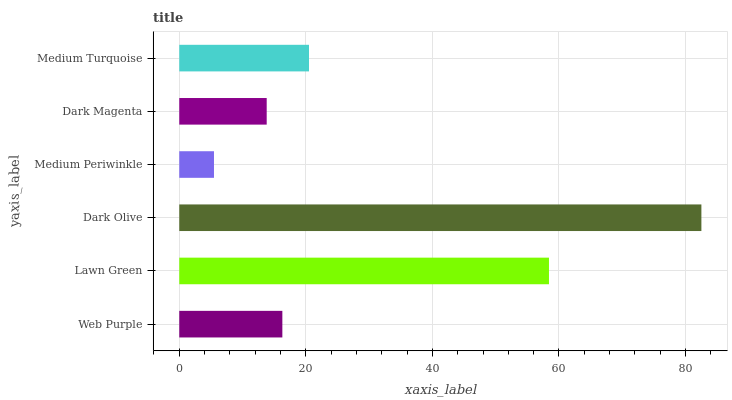Is Medium Periwinkle the minimum?
Answer yes or no. Yes. Is Dark Olive the maximum?
Answer yes or no. Yes. Is Lawn Green the minimum?
Answer yes or no. No. Is Lawn Green the maximum?
Answer yes or no. No. Is Lawn Green greater than Web Purple?
Answer yes or no. Yes. Is Web Purple less than Lawn Green?
Answer yes or no. Yes. Is Web Purple greater than Lawn Green?
Answer yes or no. No. Is Lawn Green less than Web Purple?
Answer yes or no. No. Is Medium Turquoise the high median?
Answer yes or no. Yes. Is Web Purple the low median?
Answer yes or no. Yes. Is Web Purple the high median?
Answer yes or no. No. Is Medium Periwinkle the low median?
Answer yes or no. No. 